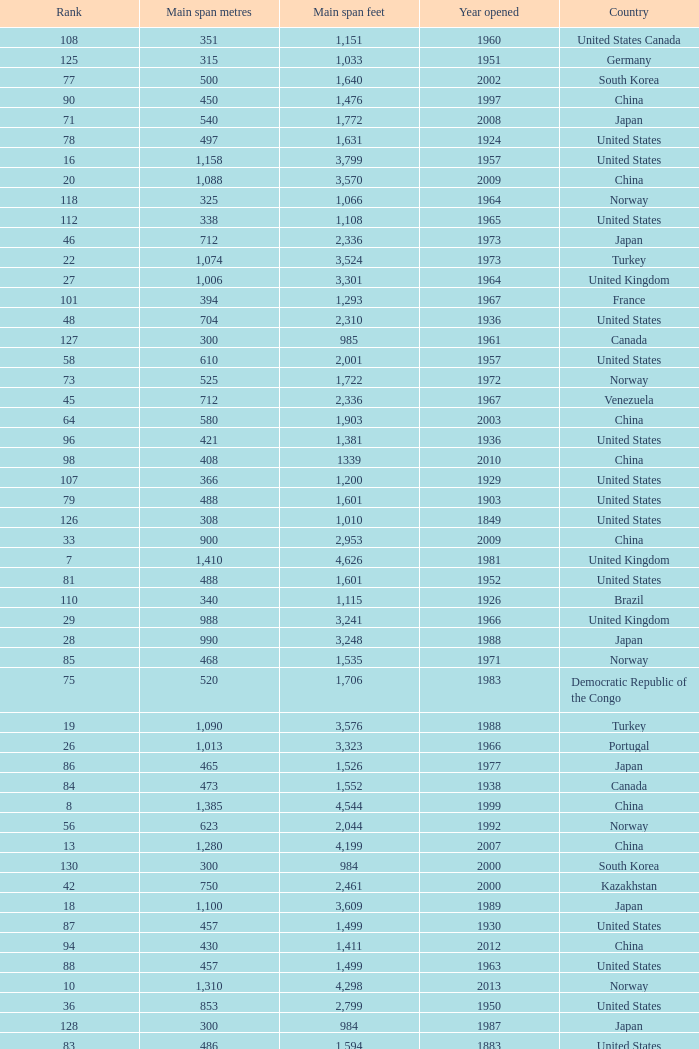What is the main span in feet from a year of 2009 or more recent with a rank less than 94 and 1,310 main span metres? 4298.0. 